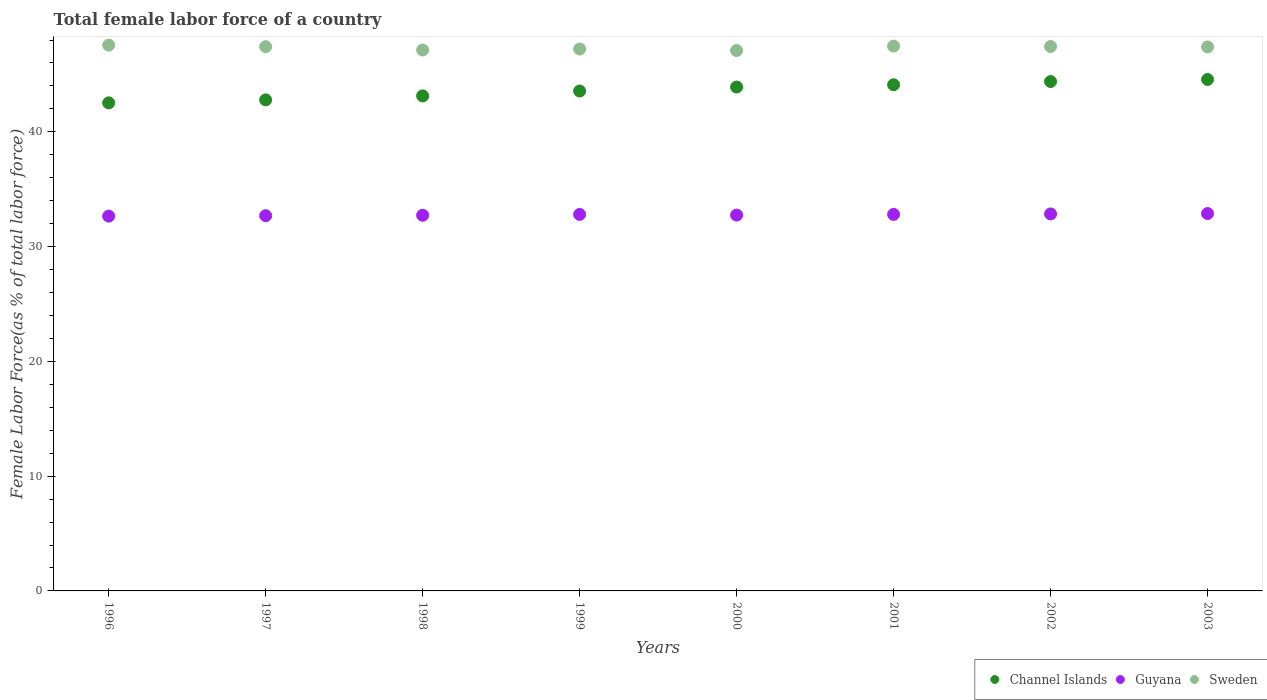What is the percentage of female labor force in Guyana in 1996?
Offer a very short reply. 32.66. Across all years, what is the maximum percentage of female labor force in Channel Islands?
Your answer should be very brief. 44.57. Across all years, what is the minimum percentage of female labor force in Guyana?
Provide a succinct answer. 32.66. What is the total percentage of female labor force in Channel Islands in the graph?
Give a very brief answer. 348.96. What is the difference between the percentage of female labor force in Channel Islands in 2000 and that in 2003?
Give a very brief answer. -0.66. What is the difference between the percentage of female labor force in Sweden in 2002 and the percentage of female labor force in Guyana in 1997?
Make the answer very short. 14.74. What is the average percentage of female labor force in Channel Islands per year?
Offer a very short reply. 43.62. In the year 2000, what is the difference between the percentage of female labor force in Sweden and percentage of female labor force in Guyana?
Provide a succinct answer. 14.34. In how many years, is the percentage of female labor force in Channel Islands greater than 46 %?
Ensure brevity in your answer.  0. What is the ratio of the percentage of female labor force in Guyana in 2001 to that in 2003?
Provide a short and direct response. 1. Is the percentage of female labor force in Sweden in 2000 less than that in 2003?
Offer a terse response. Yes. Is the difference between the percentage of female labor force in Sweden in 2000 and 2003 greater than the difference between the percentage of female labor force in Guyana in 2000 and 2003?
Your answer should be compact. No. What is the difference between the highest and the second highest percentage of female labor force in Channel Islands?
Provide a short and direct response. 0.18. What is the difference between the highest and the lowest percentage of female labor force in Guyana?
Your answer should be very brief. 0.23. Is the sum of the percentage of female labor force in Guyana in 2000 and 2001 greater than the maximum percentage of female labor force in Sweden across all years?
Your answer should be compact. Yes. Is it the case that in every year, the sum of the percentage of female labor force in Guyana and percentage of female labor force in Sweden  is greater than the percentage of female labor force in Channel Islands?
Your answer should be very brief. Yes. Is the percentage of female labor force in Channel Islands strictly less than the percentage of female labor force in Guyana over the years?
Keep it short and to the point. No. How many years are there in the graph?
Ensure brevity in your answer.  8. Are the values on the major ticks of Y-axis written in scientific E-notation?
Keep it short and to the point. No. Does the graph contain grids?
Make the answer very short. No. Where does the legend appear in the graph?
Offer a very short reply. Bottom right. How are the legend labels stacked?
Give a very brief answer. Horizontal. What is the title of the graph?
Your response must be concise. Total female labor force of a country. Does "Tunisia" appear as one of the legend labels in the graph?
Ensure brevity in your answer.  No. What is the label or title of the Y-axis?
Provide a short and direct response. Female Labor Force(as % of total labor force). What is the Female Labor Force(as % of total labor force) in Channel Islands in 1996?
Provide a succinct answer. 42.52. What is the Female Labor Force(as % of total labor force) in Guyana in 1996?
Provide a short and direct response. 32.66. What is the Female Labor Force(as % of total labor force) in Sweden in 1996?
Ensure brevity in your answer.  47.56. What is the Female Labor Force(as % of total labor force) of Channel Islands in 1997?
Keep it short and to the point. 42.79. What is the Female Labor Force(as % of total labor force) in Guyana in 1997?
Provide a succinct answer. 32.69. What is the Female Labor Force(as % of total labor force) in Sweden in 1997?
Your response must be concise. 47.42. What is the Female Labor Force(as % of total labor force) in Channel Islands in 1998?
Your answer should be very brief. 43.13. What is the Female Labor Force(as % of total labor force) of Guyana in 1998?
Your answer should be very brief. 32.73. What is the Female Labor Force(as % of total labor force) of Sweden in 1998?
Your answer should be very brief. 47.13. What is the Female Labor Force(as % of total labor force) of Channel Islands in 1999?
Your answer should be compact. 43.56. What is the Female Labor Force(as % of total labor force) in Guyana in 1999?
Offer a terse response. 32.81. What is the Female Labor Force(as % of total labor force) of Sweden in 1999?
Ensure brevity in your answer.  47.22. What is the Female Labor Force(as % of total labor force) in Channel Islands in 2000?
Ensure brevity in your answer.  43.9. What is the Female Labor Force(as % of total labor force) of Guyana in 2000?
Provide a succinct answer. 32.75. What is the Female Labor Force(as % of total labor force) of Sweden in 2000?
Ensure brevity in your answer.  47.09. What is the Female Labor Force(as % of total labor force) of Channel Islands in 2001?
Offer a terse response. 44.1. What is the Female Labor Force(as % of total labor force) in Guyana in 2001?
Ensure brevity in your answer.  32.81. What is the Female Labor Force(as % of total labor force) of Sweden in 2001?
Offer a very short reply. 47.47. What is the Female Labor Force(as % of total labor force) of Channel Islands in 2002?
Provide a succinct answer. 44.38. What is the Female Labor Force(as % of total labor force) of Guyana in 2002?
Ensure brevity in your answer.  32.85. What is the Female Labor Force(as % of total labor force) in Sweden in 2002?
Give a very brief answer. 47.44. What is the Female Labor Force(as % of total labor force) in Channel Islands in 2003?
Ensure brevity in your answer.  44.57. What is the Female Labor Force(as % of total labor force) of Guyana in 2003?
Keep it short and to the point. 32.88. What is the Female Labor Force(as % of total labor force) of Sweden in 2003?
Give a very brief answer. 47.4. Across all years, what is the maximum Female Labor Force(as % of total labor force) in Channel Islands?
Give a very brief answer. 44.57. Across all years, what is the maximum Female Labor Force(as % of total labor force) of Guyana?
Your answer should be compact. 32.88. Across all years, what is the maximum Female Labor Force(as % of total labor force) of Sweden?
Offer a terse response. 47.56. Across all years, what is the minimum Female Labor Force(as % of total labor force) of Channel Islands?
Provide a succinct answer. 42.52. Across all years, what is the minimum Female Labor Force(as % of total labor force) in Guyana?
Ensure brevity in your answer.  32.66. Across all years, what is the minimum Female Labor Force(as % of total labor force) in Sweden?
Provide a succinct answer. 47.09. What is the total Female Labor Force(as % of total labor force) of Channel Islands in the graph?
Your response must be concise. 348.96. What is the total Female Labor Force(as % of total labor force) in Guyana in the graph?
Provide a succinct answer. 262.18. What is the total Female Labor Force(as % of total labor force) of Sweden in the graph?
Offer a very short reply. 378.72. What is the difference between the Female Labor Force(as % of total labor force) in Channel Islands in 1996 and that in 1997?
Ensure brevity in your answer.  -0.26. What is the difference between the Female Labor Force(as % of total labor force) in Guyana in 1996 and that in 1997?
Offer a terse response. -0.04. What is the difference between the Female Labor Force(as % of total labor force) of Sweden in 1996 and that in 1997?
Keep it short and to the point. 0.14. What is the difference between the Female Labor Force(as % of total labor force) in Channel Islands in 1996 and that in 1998?
Provide a short and direct response. -0.61. What is the difference between the Female Labor Force(as % of total labor force) in Guyana in 1996 and that in 1998?
Your answer should be compact. -0.08. What is the difference between the Female Labor Force(as % of total labor force) of Sweden in 1996 and that in 1998?
Offer a terse response. 0.43. What is the difference between the Female Labor Force(as % of total labor force) in Channel Islands in 1996 and that in 1999?
Give a very brief answer. -1.03. What is the difference between the Female Labor Force(as % of total labor force) in Guyana in 1996 and that in 1999?
Make the answer very short. -0.15. What is the difference between the Female Labor Force(as % of total labor force) of Sweden in 1996 and that in 1999?
Provide a succinct answer. 0.34. What is the difference between the Female Labor Force(as % of total labor force) of Channel Islands in 1996 and that in 2000?
Give a very brief answer. -1.38. What is the difference between the Female Labor Force(as % of total labor force) in Guyana in 1996 and that in 2000?
Ensure brevity in your answer.  -0.09. What is the difference between the Female Labor Force(as % of total labor force) of Sweden in 1996 and that in 2000?
Make the answer very short. 0.47. What is the difference between the Female Labor Force(as % of total labor force) of Channel Islands in 1996 and that in 2001?
Your response must be concise. -1.58. What is the difference between the Female Labor Force(as % of total labor force) in Guyana in 1996 and that in 2001?
Offer a very short reply. -0.15. What is the difference between the Female Labor Force(as % of total labor force) of Sweden in 1996 and that in 2001?
Keep it short and to the point. 0.09. What is the difference between the Female Labor Force(as % of total labor force) in Channel Islands in 1996 and that in 2002?
Offer a very short reply. -1.86. What is the difference between the Female Labor Force(as % of total labor force) of Guyana in 1996 and that in 2002?
Provide a short and direct response. -0.19. What is the difference between the Female Labor Force(as % of total labor force) in Sweden in 1996 and that in 2002?
Ensure brevity in your answer.  0.12. What is the difference between the Female Labor Force(as % of total labor force) in Channel Islands in 1996 and that in 2003?
Your answer should be very brief. -2.04. What is the difference between the Female Labor Force(as % of total labor force) in Guyana in 1996 and that in 2003?
Give a very brief answer. -0.23. What is the difference between the Female Labor Force(as % of total labor force) of Sweden in 1996 and that in 2003?
Your answer should be compact. 0.16. What is the difference between the Female Labor Force(as % of total labor force) in Channel Islands in 1997 and that in 1998?
Offer a very short reply. -0.35. What is the difference between the Female Labor Force(as % of total labor force) of Guyana in 1997 and that in 1998?
Provide a short and direct response. -0.04. What is the difference between the Female Labor Force(as % of total labor force) of Sweden in 1997 and that in 1998?
Provide a succinct answer. 0.29. What is the difference between the Female Labor Force(as % of total labor force) of Channel Islands in 1997 and that in 1999?
Provide a succinct answer. -0.77. What is the difference between the Female Labor Force(as % of total labor force) of Guyana in 1997 and that in 1999?
Ensure brevity in your answer.  -0.11. What is the difference between the Female Labor Force(as % of total labor force) of Sweden in 1997 and that in 1999?
Offer a terse response. 0.2. What is the difference between the Female Labor Force(as % of total labor force) of Channel Islands in 1997 and that in 2000?
Provide a short and direct response. -1.12. What is the difference between the Female Labor Force(as % of total labor force) of Guyana in 1997 and that in 2000?
Provide a short and direct response. -0.05. What is the difference between the Female Labor Force(as % of total labor force) of Sweden in 1997 and that in 2000?
Keep it short and to the point. 0.33. What is the difference between the Female Labor Force(as % of total labor force) in Channel Islands in 1997 and that in 2001?
Give a very brief answer. -1.32. What is the difference between the Female Labor Force(as % of total labor force) of Guyana in 1997 and that in 2001?
Provide a succinct answer. -0.11. What is the difference between the Female Labor Force(as % of total labor force) of Sweden in 1997 and that in 2001?
Your response must be concise. -0.05. What is the difference between the Female Labor Force(as % of total labor force) in Channel Islands in 1997 and that in 2002?
Your answer should be compact. -1.6. What is the difference between the Female Labor Force(as % of total labor force) of Guyana in 1997 and that in 2002?
Give a very brief answer. -0.15. What is the difference between the Female Labor Force(as % of total labor force) of Sweden in 1997 and that in 2002?
Provide a succinct answer. -0.02. What is the difference between the Female Labor Force(as % of total labor force) of Channel Islands in 1997 and that in 2003?
Provide a succinct answer. -1.78. What is the difference between the Female Labor Force(as % of total labor force) in Guyana in 1997 and that in 2003?
Offer a very short reply. -0.19. What is the difference between the Female Labor Force(as % of total labor force) of Sweden in 1997 and that in 2003?
Offer a terse response. 0.02. What is the difference between the Female Labor Force(as % of total labor force) in Channel Islands in 1998 and that in 1999?
Provide a succinct answer. -0.43. What is the difference between the Female Labor Force(as % of total labor force) of Guyana in 1998 and that in 1999?
Your answer should be compact. -0.07. What is the difference between the Female Labor Force(as % of total labor force) in Sweden in 1998 and that in 1999?
Make the answer very short. -0.09. What is the difference between the Female Labor Force(as % of total labor force) in Channel Islands in 1998 and that in 2000?
Offer a terse response. -0.77. What is the difference between the Female Labor Force(as % of total labor force) in Guyana in 1998 and that in 2000?
Your answer should be very brief. -0.01. What is the difference between the Female Labor Force(as % of total labor force) of Sweden in 1998 and that in 2000?
Provide a short and direct response. 0.04. What is the difference between the Female Labor Force(as % of total labor force) in Channel Islands in 1998 and that in 2001?
Ensure brevity in your answer.  -0.97. What is the difference between the Female Labor Force(as % of total labor force) of Guyana in 1998 and that in 2001?
Ensure brevity in your answer.  -0.08. What is the difference between the Female Labor Force(as % of total labor force) in Sweden in 1998 and that in 2001?
Make the answer very short. -0.34. What is the difference between the Female Labor Force(as % of total labor force) of Channel Islands in 1998 and that in 2002?
Ensure brevity in your answer.  -1.25. What is the difference between the Female Labor Force(as % of total labor force) of Guyana in 1998 and that in 2002?
Ensure brevity in your answer.  -0.11. What is the difference between the Female Labor Force(as % of total labor force) in Sweden in 1998 and that in 2002?
Provide a succinct answer. -0.31. What is the difference between the Female Labor Force(as % of total labor force) in Channel Islands in 1998 and that in 2003?
Offer a terse response. -1.43. What is the difference between the Female Labor Force(as % of total labor force) in Guyana in 1998 and that in 2003?
Ensure brevity in your answer.  -0.15. What is the difference between the Female Labor Force(as % of total labor force) in Sweden in 1998 and that in 2003?
Offer a terse response. -0.27. What is the difference between the Female Labor Force(as % of total labor force) of Channel Islands in 1999 and that in 2000?
Offer a terse response. -0.34. What is the difference between the Female Labor Force(as % of total labor force) in Guyana in 1999 and that in 2000?
Keep it short and to the point. 0.06. What is the difference between the Female Labor Force(as % of total labor force) in Sweden in 1999 and that in 2000?
Offer a terse response. 0.13. What is the difference between the Female Labor Force(as % of total labor force) in Channel Islands in 1999 and that in 2001?
Offer a terse response. -0.55. What is the difference between the Female Labor Force(as % of total labor force) in Guyana in 1999 and that in 2001?
Provide a short and direct response. -0. What is the difference between the Female Labor Force(as % of total labor force) of Sweden in 1999 and that in 2001?
Your answer should be very brief. -0.25. What is the difference between the Female Labor Force(as % of total labor force) of Channel Islands in 1999 and that in 2002?
Give a very brief answer. -0.82. What is the difference between the Female Labor Force(as % of total labor force) of Guyana in 1999 and that in 2002?
Provide a succinct answer. -0.04. What is the difference between the Female Labor Force(as % of total labor force) in Sweden in 1999 and that in 2002?
Provide a short and direct response. -0.22. What is the difference between the Female Labor Force(as % of total labor force) of Channel Islands in 1999 and that in 2003?
Provide a short and direct response. -1.01. What is the difference between the Female Labor Force(as % of total labor force) of Guyana in 1999 and that in 2003?
Offer a very short reply. -0.07. What is the difference between the Female Labor Force(as % of total labor force) in Sweden in 1999 and that in 2003?
Your response must be concise. -0.18. What is the difference between the Female Labor Force(as % of total labor force) in Channel Islands in 2000 and that in 2001?
Give a very brief answer. -0.2. What is the difference between the Female Labor Force(as % of total labor force) in Guyana in 2000 and that in 2001?
Your response must be concise. -0.06. What is the difference between the Female Labor Force(as % of total labor force) of Sweden in 2000 and that in 2001?
Your response must be concise. -0.38. What is the difference between the Female Labor Force(as % of total labor force) in Channel Islands in 2000 and that in 2002?
Give a very brief answer. -0.48. What is the difference between the Female Labor Force(as % of total labor force) of Sweden in 2000 and that in 2002?
Offer a very short reply. -0.35. What is the difference between the Female Labor Force(as % of total labor force) of Channel Islands in 2000 and that in 2003?
Your response must be concise. -0.66. What is the difference between the Female Labor Force(as % of total labor force) in Guyana in 2000 and that in 2003?
Provide a succinct answer. -0.13. What is the difference between the Female Labor Force(as % of total labor force) of Sweden in 2000 and that in 2003?
Offer a terse response. -0.31. What is the difference between the Female Labor Force(as % of total labor force) of Channel Islands in 2001 and that in 2002?
Your answer should be compact. -0.28. What is the difference between the Female Labor Force(as % of total labor force) in Guyana in 2001 and that in 2002?
Your answer should be very brief. -0.04. What is the difference between the Female Labor Force(as % of total labor force) in Sweden in 2001 and that in 2002?
Keep it short and to the point. 0.03. What is the difference between the Female Labor Force(as % of total labor force) in Channel Islands in 2001 and that in 2003?
Offer a very short reply. -0.46. What is the difference between the Female Labor Force(as % of total labor force) of Guyana in 2001 and that in 2003?
Offer a terse response. -0.07. What is the difference between the Female Labor Force(as % of total labor force) in Sweden in 2001 and that in 2003?
Keep it short and to the point. 0.07. What is the difference between the Female Labor Force(as % of total labor force) of Channel Islands in 2002 and that in 2003?
Your answer should be very brief. -0.18. What is the difference between the Female Labor Force(as % of total labor force) in Guyana in 2002 and that in 2003?
Your answer should be compact. -0.03. What is the difference between the Female Labor Force(as % of total labor force) in Sweden in 2002 and that in 2003?
Ensure brevity in your answer.  0.04. What is the difference between the Female Labor Force(as % of total labor force) of Channel Islands in 1996 and the Female Labor Force(as % of total labor force) of Guyana in 1997?
Make the answer very short. 9.83. What is the difference between the Female Labor Force(as % of total labor force) in Channel Islands in 1996 and the Female Labor Force(as % of total labor force) in Sweden in 1997?
Give a very brief answer. -4.89. What is the difference between the Female Labor Force(as % of total labor force) in Guyana in 1996 and the Female Labor Force(as % of total labor force) in Sweden in 1997?
Your answer should be very brief. -14.76. What is the difference between the Female Labor Force(as % of total labor force) in Channel Islands in 1996 and the Female Labor Force(as % of total labor force) in Guyana in 1998?
Ensure brevity in your answer.  9.79. What is the difference between the Female Labor Force(as % of total labor force) of Channel Islands in 1996 and the Female Labor Force(as % of total labor force) of Sweden in 1998?
Ensure brevity in your answer.  -4.61. What is the difference between the Female Labor Force(as % of total labor force) of Guyana in 1996 and the Female Labor Force(as % of total labor force) of Sweden in 1998?
Ensure brevity in your answer.  -14.47. What is the difference between the Female Labor Force(as % of total labor force) of Channel Islands in 1996 and the Female Labor Force(as % of total labor force) of Guyana in 1999?
Offer a terse response. 9.72. What is the difference between the Female Labor Force(as % of total labor force) of Channel Islands in 1996 and the Female Labor Force(as % of total labor force) of Sweden in 1999?
Your response must be concise. -4.69. What is the difference between the Female Labor Force(as % of total labor force) of Guyana in 1996 and the Female Labor Force(as % of total labor force) of Sweden in 1999?
Offer a very short reply. -14.56. What is the difference between the Female Labor Force(as % of total labor force) of Channel Islands in 1996 and the Female Labor Force(as % of total labor force) of Guyana in 2000?
Ensure brevity in your answer.  9.78. What is the difference between the Female Labor Force(as % of total labor force) of Channel Islands in 1996 and the Female Labor Force(as % of total labor force) of Sweden in 2000?
Provide a short and direct response. -4.57. What is the difference between the Female Labor Force(as % of total labor force) in Guyana in 1996 and the Female Labor Force(as % of total labor force) in Sweden in 2000?
Offer a very short reply. -14.43. What is the difference between the Female Labor Force(as % of total labor force) of Channel Islands in 1996 and the Female Labor Force(as % of total labor force) of Guyana in 2001?
Ensure brevity in your answer.  9.72. What is the difference between the Female Labor Force(as % of total labor force) of Channel Islands in 1996 and the Female Labor Force(as % of total labor force) of Sweden in 2001?
Provide a succinct answer. -4.95. What is the difference between the Female Labor Force(as % of total labor force) of Guyana in 1996 and the Female Labor Force(as % of total labor force) of Sweden in 2001?
Keep it short and to the point. -14.81. What is the difference between the Female Labor Force(as % of total labor force) of Channel Islands in 1996 and the Female Labor Force(as % of total labor force) of Guyana in 2002?
Provide a short and direct response. 9.68. What is the difference between the Female Labor Force(as % of total labor force) of Channel Islands in 1996 and the Female Labor Force(as % of total labor force) of Sweden in 2002?
Your response must be concise. -4.91. What is the difference between the Female Labor Force(as % of total labor force) in Guyana in 1996 and the Female Labor Force(as % of total labor force) in Sweden in 2002?
Provide a succinct answer. -14.78. What is the difference between the Female Labor Force(as % of total labor force) of Channel Islands in 1996 and the Female Labor Force(as % of total labor force) of Guyana in 2003?
Make the answer very short. 9.64. What is the difference between the Female Labor Force(as % of total labor force) of Channel Islands in 1996 and the Female Labor Force(as % of total labor force) of Sweden in 2003?
Keep it short and to the point. -4.87. What is the difference between the Female Labor Force(as % of total labor force) of Guyana in 1996 and the Female Labor Force(as % of total labor force) of Sweden in 2003?
Ensure brevity in your answer.  -14.74. What is the difference between the Female Labor Force(as % of total labor force) in Channel Islands in 1997 and the Female Labor Force(as % of total labor force) in Guyana in 1998?
Keep it short and to the point. 10.05. What is the difference between the Female Labor Force(as % of total labor force) of Channel Islands in 1997 and the Female Labor Force(as % of total labor force) of Sweden in 1998?
Your response must be concise. -4.34. What is the difference between the Female Labor Force(as % of total labor force) of Guyana in 1997 and the Female Labor Force(as % of total labor force) of Sweden in 1998?
Offer a very short reply. -14.44. What is the difference between the Female Labor Force(as % of total labor force) in Channel Islands in 1997 and the Female Labor Force(as % of total labor force) in Guyana in 1999?
Provide a short and direct response. 9.98. What is the difference between the Female Labor Force(as % of total labor force) of Channel Islands in 1997 and the Female Labor Force(as % of total labor force) of Sweden in 1999?
Your response must be concise. -4.43. What is the difference between the Female Labor Force(as % of total labor force) of Guyana in 1997 and the Female Labor Force(as % of total labor force) of Sweden in 1999?
Your response must be concise. -14.52. What is the difference between the Female Labor Force(as % of total labor force) of Channel Islands in 1997 and the Female Labor Force(as % of total labor force) of Guyana in 2000?
Give a very brief answer. 10.04. What is the difference between the Female Labor Force(as % of total labor force) of Channel Islands in 1997 and the Female Labor Force(as % of total labor force) of Sweden in 2000?
Offer a terse response. -4.3. What is the difference between the Female Labor Force(as % of total labor force) of Guyana in 1997 and the Female Labor Force(as % of total labor force) of Sweden in 2000?
Provide a short and direct response. -14.4. What is the difference between the Female Labor Force(as % of total labor force) of Channel Islands in 1997 and the Female Labor Force(as % of total labor force) of Guyana in 2001?
Provide a succinct answer. 9.98. What is the difference between the Female Labor Force(as % of total labor force) of Channel Islands in 1997 and the Female Labor Force(as % of total labor force) of Sweden in 2001?
Provide a short and direct response. -4.68. What is the difference between the Female Labor Force(as % of total labor force) in Guyana in 1997 and the Female Labor Force(as % of total labor force) in Sweden in 2001?
Provide a short and direct response. -14.78. What is the difference between the Female Labor Force(as % of total labor force) in Channel Islands in 1997 and the Female Labor Force(as % of total labor force) in Guyana in 2002?
Give a very brief answer. 9.94. What is the difference between the Female Labor Force(as % of total labor force) of Channel Islands in 1997 and the Female Labor Force(as % of total labor force) of Sweden in 2002?
Provide a succinct answer. -4.65. What is the difference between the Female Labor Force(as % of total labor force) in Guyana in 1997 and the Female Labor Force(as % of total labor force) in Sweden in 2002?
Offer a very short reply. -14.74. What is the difference between the Female Labor Force(as % of total labor force) in Channel Islands in 1997 and the Female Labor Force(as % of total labor force) in Guyana in 2003?
Your answer should be compact. 9.91. What is the difference between the Female Labor Force(as % of total labor force) in Channel Islands in 1997 and the Female Labor Force(as % of total labor force) in Sweden in 2003?
Offer a very short reply. -4.61. What is the difference between the Female Labor Force(as % of total labor force) of Guyana in 1997 and the Female Labor Force(as % of total labor force) of Sweden in 2003?
Keep it short and to the point. -14.7. What is the difference between the Female Labor Force(as % of total labor force) in Channel Islands in 1998 and the Female Labor Force(as % of total labor force) in Guyana in 1999?
Make the answer very short. 10.33. What is the difference between the Female Labor Force(as % of total labor force) of Channel Islands in 1998 and the Female Labor Force(as % of total labor force) of Sweden in 1999?
Your response must be concise. -4.08. What is the difference between the Female Labor Force(as % of total labor force) of Guyana in 1998 and the Female Labor Force(as % of total labor force) of Sweden in 1999?
Your answer should be compact. -14.48. What is the difference between the Female Labor Force(as % of total labor force) of Channel Islands in 1998 and the Female Labor Force(as % of total labor force) of Guyana in 2000?
Provide a short and direct response. 10.38. What is the difference between the Female Labor Force(as % of total labor force) in Channel Islands in 1998 and the Female Labor Force(as % of total labor force) in Sweden in 2000?
Provide a succinct answer. -3.96. What is the difference between the Female Labor Force(as % of total labor force) in Guyana in 1998 and the Female Labor Force(as % of total labor force) in Sweden in 2000?
Your answer should be very brief. -14.36. What is the difference between the Female Labor Force(as % of total labor force) in Channel Islands in 1998 and the Female Labor Force(as % of total labor force) in Guyana in 2001?
Your answer should be very brief. 10.32. What is the difference between the Female Labor Force(as % of total labor force) of Channel Islands in 1998 and the Female Labor Force(as % of total labor force) of Sweden in 2001?
Make the answer very short. -4.34. What is the difference between the Female Labor Force(as % of total labor force) in Guyana in 1998 and the Female Labor Force(as % of total labor force) in Sweden in 2001?
Keep it short and to the point. -14.74. What is the difference between the Female Labor Force(as % of total labor force) of Channel Islands in 1998 and the Female Labor Force(as % of total labor force) of Guyana in 2002?
Make the answer very short. 10.28. What is the difference between the Female Labor Force(as % of total labor force) of Channel Islands in 1998 and the Female Labor Force(as % of total labor force) of Sweden in 2002?
Give a very brief answer. -4.31. What is the difference between the Female Labor Force(as % of total labor force) in Guyana in 1998 and the Female Labor Force(as % of total labor force) in Sweden in 2002?
Keep it short and to the point. -14.71. What is the difference between the Female Labor Force(as % of total labor force) of Channel Islands in 1998 and the Female Labor Force(as % of total labor force) of Guyana in 2003?
Your answer should be compact. 10.25. What is the difference between the Female Labor Force(as % of total labor force) in Channel Islands in 1998 and the Female Labor Force(as % of total labor force) in Sweden in 2003?
Give a very brief answer. -4.27. What is the difference between the Female Labor Force(as % of total labor force) in Guyana in 1998 and the Female Labor Force(as % of total labor force) in Sweden in 2003?
Ensure brevity in your answer.  -14.67. What is the difference between the Female Labor Force(as % of total labor force) of Channel Islands in 1999 and the Female Labor Force(as % of total labor force) of Guyana in 2000?
Make the answer very short. 10.81. What is the difference between the Female Labor Force(as % of total labor force) of Channel Islands in 1999 and the Female Labor Force(as % of total labor force) of Sweden in 2000?
Ensure brevity in your answer.  -3.53. What is the difference between the Female Labor Force(as % of total labor force) in Guyana in 1999 and the Female Labor Force(as % of total labor force) in Sweden in 2000?
Make the answer very short. -14.28. What is the difference between the Female Labor Force(as % of total labor force) in Channel Islands in 1999 and the Female Labor Force(as % of total labor force) in Guyana in 2001?
Give a very brief answer. 10.75. What is the difference between the Female Labor Force(as % of total labor force) of Channel Islands in 1999 and the Female Labor Force(as % of total labor force) of Sweden in 2001?
Offer a very short reply. -3.91. What is the difference between the Female Labor Force(as % of total labor force) in Guyana in 1999 and the Female Labor Force(as % of total labor force) in Sweden in 2001?
Provide a succinct answer. -14.66. What is the difference between the Female Labor Force(as % of total labor force) in Channel Islands in 1999 and the Female Labor Force(as % of total labor force) in Guyana in 2002?
Your response must be concise. 10.71. What is the difference between the Female Labor Force(as % of total labor force) of Channel Islands in 1999 and the Female Labor Force(as % of total labor force) of Sweden in 2002?
Give a very brief answer. -3.88. What is the difference between the Female Labor Force(as % of total labor force) in Guyana in 1999 and the Female Labor Force(as % of total labor force) in Sweden in 2002?
Offer a very short reply. -14.63. What is the difference between the Female Labor Force(as % of total labor force) in Channel Islands in 1999 and the Female Labor Force(as % of total labor force) in Guyana in 2003?
Keep it short and to the point. 10.68. What is the difference between the Female Labor Force(as % of total labor force) of Channel Islands in 1999 and the Female Labor Force(as % of total labor force) of Sweden in 2003?
Your answer should be very brief. -3.84. What is the difference between the Female Labor Force(as % of total labor force) in Guyana in 1999 and the Female Labor Force(as % of total labor force) in Sweden in 2003?
Your answer should be compact. -14.59. What is the difference between the Female Labor Force(as % of total labor force) of Channel Islands in 2000 and the Female Labor Force(as % of total labor force) of Guyana in 2001?
Keep it short and to the point. 11.09. What is the difference between the Female Labor Force(as % of total labor force) in Channel Islands in 2000 and the Female Labor Force(as % of total labor force) in Sweden in 2001?
Offer a terse response. -3.57. What is the difference between the Female Labor Force(as % of total labor force) in Guyana in 2000 and the Female Labor Force(as % of total labor force) in Sweden in 2001?
Keep it short and to the point. -14.72. What is the difference between the Female Labor Force(as % of total labor force) of Channel Islands in 2000 and the Female Labor Force(as % of total labor force) of Guyana in 2002?
Your answer should be compact. 11.05. What is the difference between the Female Labor Force(as % of total labor force) of Channel Islands in 2000 and the Female Labor Force(as % of total labor force) of Sweden in 2002?
Your answer should be very brief. -3.54. What is the difference between the Female Labor Force(as % of total labor force) of Guyana in 2000 and the Female Labor Force(as % of total labor force) of Sweden in 2002?
Keep it short and to the point. -14.69. What is the difference between the Female Labor Force(as % of total labor force) of Channel Islands in 2000 and the Female Labor Force(as % of total labor force) of Guyana in 2003?
Keep it short and to the point. 11.02. What is the difference between the Female Labor Force(as % of total labor force) of Channel Islands in 2000 and the Female Labor Force(as % of total labor force) of Sweden in 2003?
Make the answer very short. -3.5. What is the difference between the Female Labor Force(as % of total labor force) in Guyana in 2000 and the Female Labor Force(as % of total labor force) in Sweden in 2003?
Keep it short and to the point. -14.65. What is the difference between the Female Labor Force(as % of total labor force) of Channel Islands in 2001 and the Female Labor Force(as % of total labor force) of Guyana in 2002?
Your answer should be compact. 11.26. What is the difference between the Female Labor Force(as % of total labor force) of Channel Islands in 2001 and the Female Labor Force(as % of total labor force) of Sweden in 2002?
Your answer should be compact. -3.33. What is the difference between the Female Labor Force(as % of total labor force) of Guyana in 2001 and the Female Labor Force(as % of total labor force) of Sweden in 2002?
Give a very brief answer. -14.63. What is the difference between the Female Labor Force(as % of total labor force) in Channel Islands in 2001 and the Female Labor Force(as % of total labor force) in Guyana in 2003?
Provide a succinct answer. 11.22. What is the difference between the Female Labor Force(as % of total labor force) of Channel Islands in 2001 and the Female Labor Force(as % of total labor force) of Sweden in 2003?
Offer a very short reply. -3.29. What is the difference between the Female Labor Force(as % of total labor force) of Guyana in 2001 and the Female Labor Force(as % of total labor force) of Sweden in 2003?
Ensure brevity in your answer.  -14.59. What is the difference between the Female Labor Force(as % of total labor force) in Channel Islands in 2002 and the Female Labor Force(as % of total labor force) in Guyana in 2003?
Your answer should be compact. 11.5. What is the difference between the Female Labor Force(as % of total labor force) in Channel Islands in 2002 and the Female Labor Force(as % of total labor force) in Sweden in 2003?
Your answer should be very brief. -3.01. What is the difference between the Female Labor Force(as % of total labor force) in Guyana in 2002 and the Female Labor Force(as % of total labor force) in Sweden in 2003?
Offer a very short reply. -14.55. What is the average Female Labor Force(as % of total labor force) of Channel Islands per year?
Provide a succinct answer. 43.62. What is the average Female Labor Force(as % of total labor force) in Guyana per year?
Provide a succinct answer. 32.77. What is the average Female Labor Force(as % of total labor force) of Sweden per year?
Offer a very short reply. 47.34. In the year 1996, what is the difference between the Female Labor Force(as % of total labor force) in Channel Islands and Female Labor Force(as % of total labor force) in Guyana?
Your response must be concise. 9.87. In the year 1996, what is the difference between the Female Labor Force(as % of total labor force) of Channel Islands and Female Labor Force(as % of total labor force) of Sweden?
Provide a short and direct response. -5.03. In the year 1996, what is the difference between the Female Labor Force(as % of total labor force) in Guyana and Female Labor Force(as % of total labor force) in Sweden?
Make the answer very short. -14.9. In the year 1997, what is the difference between the Female Labor Force(as % of total labor force) of Channel Islands and Female Labor Force(as % of total labor force) of Guyana?
Keep it short and to the point. 10.09. In the year 1997, what is the difference between the Female Labor Force(as % of total labor force) of Channel Islands and Female Labor Force(as % of total labor force) of Sweden?
Offer a very short reply. -4.63. In the year 1997, what is the difference between the Female Labor Force(as % of total labor force) in Guyana and Female Labor Force(as % of total labor force) in Sweden?
Make the answer very short. -14.72. In the year 1998, what is the difference between the Female Labor Force(as % of total labor force) of Channel Islands and Female Labor Force(as % of total labor force) of Guyana?
Make the answer very short. 10.4. In the year 1998, what is the difference between the Female Labor Force(as % of total labor force) in Channel Islands and Female Labor Force(as % of total labor force) in Sweden?
Keep it short and to the point. -4. In the year 1998, what is the difference between the Female Labor Force(as % of total labor force) of Guyana and Female Labor Force(as % of total labor force) of Sweden?
Your response must be concise. -14.4. In the year 1999, what is the difference between the Female Labor Force(as % of total labor force) in Channel Islands and Female Labor Force(as % of total labor force) in Guyana?
Your response must be concise. 10.75. In the year 1999, what is the difference between the Female Labor Force(as % of total labor force) in Channel Islands and Female Labor Force(as % of total labor force) in Sweden?
Give a very brief answer. -3.66. In the year 1999, what is the difference between the Female Labor Force(as % of total labor force) in Guyana and Female Labor Force(as % of total labor force) in Sweden?
Your response must be concise. -14.41. In the year 2000, what is the difference between the Female Labor Force(as % of total labor force) of Channel Islands and Female Labor Force(as % of total labor force) of Guyana?
Provide a short and direct response. 11.15. In the year 2000, what is the difference between the Female Labor Force(as % of total labor force) of Channel Islands and Female Labor Force(as % of total labor force) of Sweden?
Ensure brevity in your answer.  -3.19. In the year 2000, what is the difference between the Female Labor Force(as % of total labor force) of Guyana and Female Labor Force(as % of total labor force) of Sweden?
Ensure brevity in your answer.  -14.34. In the year 2001, what is the difference between the Female Labor Force(as % of total labor force) in Channel Islands and Female Labor Force(as % of total labor force) in Guyana?
Offer a very short reply. 11.3. In the year 2001, what is the difference between the Female Labor Force(as % of total labor force) of Channel Islands and Female Labor Force(as % of total labor force) of Sweden?
Provide a succinct answer. -3.37. In the year 2001, what is the difference between the Female Labor Force(as % of total labor force) in Guyana and Female Labor Force(as % of total labor force) in Sweden?
Your response must be concise. -14.66. In the year 2002, what is the difference between the Female Labor Force(as % of total labor force) in Channel Islands and Female Labor Force(as % of total labor force) in Guyana?
Give a very brief answer. 11.54. In the year 2002, what is the difference between the Female Labor Force(as % of total labor force) in Channel Islands and Female Labor Force(as % of total labor force) in Sweden?
Give a very brief answer. -3.05. In the year 2002, what is the difference between the Female Labor Force(as % of total labor force) in Guyana and Female Labor Force(as % of total labor force) in Sweden?
Provide a succinct answer. -14.59. In the year 2003, what is the difference between the Female Labor Force(as % of total labor force) of Channel Islands and Female Labor Force(as % of total labor force) of Guyana?
Your response must be concise. 11.68. In the year 2003, what is the difference between the Female Labor Force(as % of total labor force) in Channel Islands and Female Labor Force(as % of total labor force) in Sweden?
Offer a very short reply. -2.83. In the year 2003, what is the difference between the Female Labor Force(as % of total labor force) of Guyana and Female Labor Force(as % of total labor force) of Sweden?
Make the answer very short. -14.52. What is the ratio of the Female Labor Force(as % of total labor force) of Channel Islands in 1996 to that in 1998?
Offer a very short reply. 0.99. What is the ratio of the Female Labor Force(as % of total labor force) in Guyana in 1996 to that in 1998?
Provide a succinct answer. 1. What is the ratio of the Female Labor Force(as % of total labor force) in Sweden in 1996 to that in 1998?
Offer a very short reply. 1.01. What is the ratio of the Female Labor Force(as % of total labor force) in Channel Islands in 1996 to that in 1999?
Make the answer very short. 0.98. What is the ratio of the Female Labor Force(as % of total labor force) of Guyana in 1996 to that in 1999?
Give a very brief answer. 1. What is the ratio of the Female Labor Force(as % of total labor force) of Channel Islands in 1996 to that in 2000?
Your response must be concise. 0.97. What is the ratio of the Female Labor Force(as % of total labor force) of Guyana in 1996 to that in 2000?
Ensure brevity in your answer.  1. What is the ratio of the Female Labor Force(as % of total labor force) in Sweden in 1996 to that in 2000?
Provide a succinct answer. 1.01. What is the ratio of the Female Labor Force(as % of total labor force) in Channel Islands in 1996 to that in 2001?
Offer a terse response. 0.96. What is the ratio of the Female Labor Force(as % of total labor force) of Sweden in 1996 to that in 2001?
Offer a very short reply. 1. What is the ratio of the Female Labor Force(as % of total labor force) in Channel Islands in 1996 to that in 2002?
Provide a short and direct response. 0.96. What is the ratio of the Female Labor Force(as % of total labor force) of Guyana in 1996 to that in 2002?
Provide a short and direct response. 0.99. What is the ratio of the Female Labor Force(as % of total labor force) in Channel Islands in 1996 to that in 2003?
Your answer should be compact. 0.95. What is the ratio of the Female Labor Force(as % of total labor force) of Sweden in 1996 to that in 2003?
Provide a succinct answer. 1. What is the ratio of the Female Labor Force(as % of total labor force) of Channel Islands in 1997 to that in 1998?
Offer a terse response. 0.99. What is the ratio of the Female Labor Force(as % of total labor force) in Channel Islands in 1997 to that in 1999?
Provide a short and direct response. 0.98. What is the ratio of the Female Labor Force(as % of total labor force) in Guyana in 1997 to that in 1999?
Keep it short and to the point. 1. What is the ratio of the Female Labor Force(as % of total labor force) of Channel Islands in 1997 to that in 2000?
Make the answer very short. 0.97. What is the ratio of the Female Labor Force(as % of total labor force) in Guyana in 1997 to that in 2000?
Ensure brevity in your answer.  1. What is the ratio of the Female Labor Force(as % of total labor force) of Sweden in 1997 to that in 2000?
Keep it short and to the point. 1.01. What is the ratio of the Female Labor Force(as % of total labor force) of Channel Islands in 1997 to that in 2001?
Your answer should be very brief. 0.97. What is the ratio of the Female Labor Force(as % of total labor force) in Sweden in 1997 to that in 2001?
Give a very brief answer. 1. What is the ratio of the Female Labor Force(as % of total labor force) in Channel Islands in 1997 to that in 2002?
Provide a short and direct response. 0.96. What is the ratio of the Female Labor Force(as % of total labor force) of Guyana in 1997 to that in 2002?
Keep it short and to the point. 1. What is the ratio of the Female Labor Force(as % of total labor force) of Channel Islands in 1997 to that in 2003?
Offer a terse response. 0.96. What is the ratio of the Female Labor Force(as % of total labor force) in Sweden in 1997 to that in 2003?
Give a very brief answer. 1. What is the ratio of the Female Labor Force(as % of total labor force) in Channel Islands in 1998 to that in 1999?
Offer a terse response. 0.99. What is the ratio of the Female Labor Force(as % of total labor force) of Guyana in 1998 to that in 1999?
Make the answer very short. 1. What is the ratio of the Female Labor Force(as % of total labor force) of Channel Islands in 1998 to that in 2000?
Offer a terse response. 0.98. What is the ratio of the Female Labor Force(as % of total labor force) in Guyana in 1998 to that in 2000?
Your answer should be compact. 1. What is the ratio of the Female Labor Force(as % of total labor force) in Sweden in 1998 to that in 2000?
Your answer should be compact. 1. What is the ratio of the Female Labor Force(as % of total labor force) in Channel Islands in 1998 to that in 2001?
Your answer should be very brief. 0.98. What is the ratio of the Female Labor Force(as % of total labor force) in Channel Islands in 1998 to that in 2002?
Keep it short and to the point. 0.97. What is the ratio of the Female Labor Force(as % of total labor force) of Sweden in 1998 to that in 2002?
Your response must be concise. 0.99. What is the ratio of the Female Labor Force(as % of total labor force) of Channel Islands in 1998 to that in 2003?
Ensure brevity in your answer.  0.97. What is the ratio of the Female Labor Force(as % of total labor force) in Channel Islands in 1999 to that in 2001?
Offer a terse response. 0.99. What is the ratio of the Female Labor Force(as % of total labor force) in Guyana in 1999 to that in 2001?
Your answer should be very brief. 1. What is the ratio of the Female Labor Force(as % of total labor force) of Sweden in 1999 to that in 2001?
Provide a succinct answer. 0.99. What is the ratio of the Female Labor Force(as % of total labor force) of Channel Islands in 1999 to that in 2002?
Make the answer very short. 0.98. What is the ratio of the Female Labor Force(as % of total labor force) of Sweden in 1999 to that in 2002?
Keep it short and to the point. 1. What is the ratio of the Female Labor Force(as % of total labor force) of Channel Islands in 1999 to that in 2003?
Your answer should be compact. 0.98. What is the ratio of the Female Labor Force(as % of total labor force) in Guyana in 1999 to that in 2003?
Make the answer very short. 1. What is the ratio of the Female Labor Force(as % of total labor force) in Sweden in 1999 to that in 2003?
Ensure brevity in your answer.  1. What is the ratio of the Female Labor Force(as % of total labor force) in Guyana in 2000 to that in 2001?
Keep it short and to the point. 1. What is the ratio of the Female Labor Force(as % of total labor force) in Sweden in 2000 to that in 2001?
Provide a succinct answer. 0.99. What is the ratio of the Female Labor Force(as % of total labor force) in Channel Islands in 2000 to that in 2002?
Offer a very short reply. 0.99. What is the ratio of the Female Labor Force(as % of total labor force) in Sweden in 2000 to that in 2002?
Your answer should be compact. 0.99. What is the ratio of the Female Labor Force(as % of total labor force) in Channel Islands in 2000 to that in 2003?
Make the answer very short. 0.99. What is the ratio of the Female Labor Force(as % of total labor force) of Guyana in 2001 to that in 2003?
Make the answer very short. 1. What is the ratio of the Female Labor Force(as % of total labor force) in Channel Islands in 2002 to that in 2003?
Make the answer very short. 1. What is the difference between the highest and the second highest Female Labor Force(as % of total labor force) of Channel Islands?
Your answer should be compact. 0.18. What is the difference between the highest and the second highest Female Labor Force(as % of total labor force) in Guyana?
Provide a short and direct response. 0.03. What is the difference between the highest and the second highest Female Labor Force(as % of total labor force) of Sweden?
Keep it short and to the point. 0.09. What is the difference between the highest and the lowest Female Labor Force(as % of total labor force) in Channel Islands?
Your answer should be compact. 2.04. What is the difference between the highest and the lowest Female Labor Force(as % of total labor force) of Guyana?
Offer a terse response. 0.23. What is the difference between the highest and the lowest Female Labor Force(as % of total labor force) of Sweden?
Offer a very short reply. 0.47. 